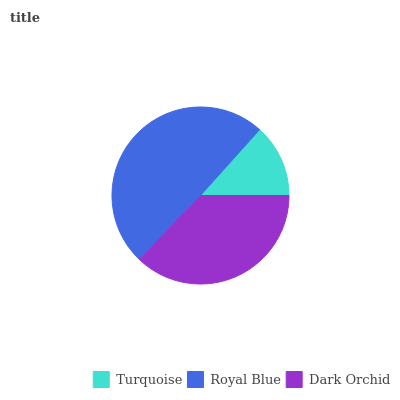Is Turquoise the minimum?
Answer yes or no. Yes. Is Royal Blue the maximum?
Answer yes or no. Yes. Is Dark Orchid the minimum?
Answer yes or no. No. Is Dark Orchid the maximum?
Answer yes or no. No. Is Royal Blue greater than Dark Orchid?
Answer yes or no. Yes. Is Dark Orchid less than Royal Blue?
Answer yes or no. Yes. Is Dark Orchid greater than Royal Blue?
Answer yes or no. No. Is Royal Blue less than Dark Orchid?
Answer yes or no. No. Is Dark Orchid the high median?
Answer yes or no. Yes. Is Dark Orchid the low median?
Answer yes or no. Yes. Is Turquoise the high median?
Answer yes or no. No. Is Turquoise the low median?
Answer yes or no. No. 